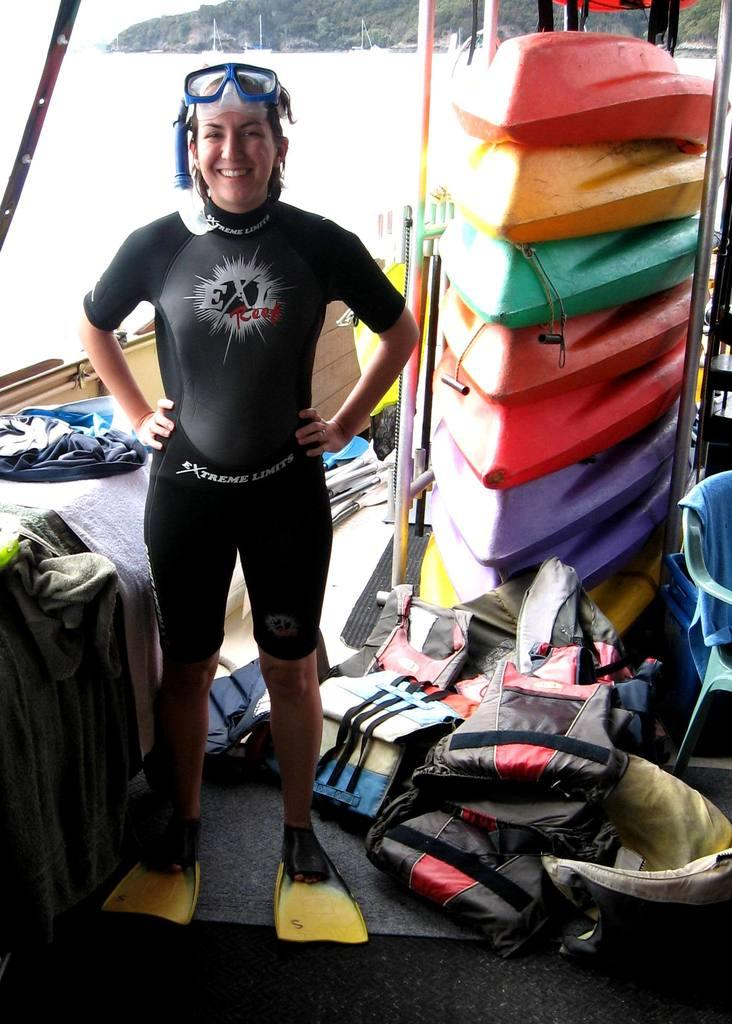<image>
Give a short and clear explanation of the subsequent image. Extreme Limits is the brand of wet suit the woman is wearing. 